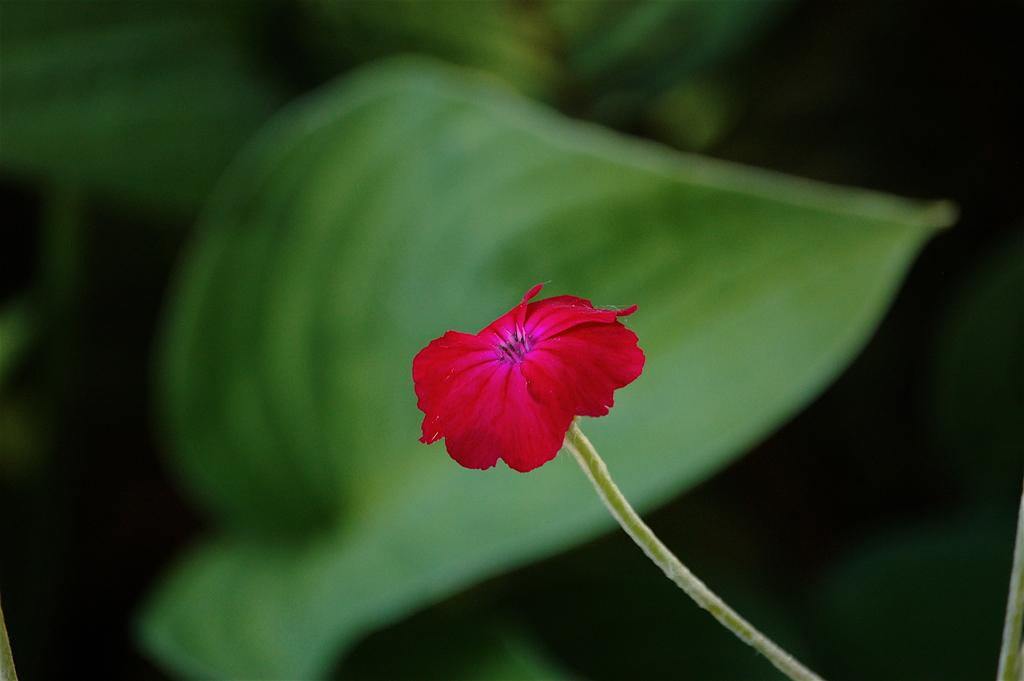What is the main subject of the image? There is a flower in the image. Can you describe the colors of the flower? The flower has red and pink colors. What else can be seen in the background of the image? There are leaves visible in the background of the image. How does the zephyr affect the flower in the image? There is no mention of a zephyr or any wind in the image, so we cannot determine its effect on the flower. 